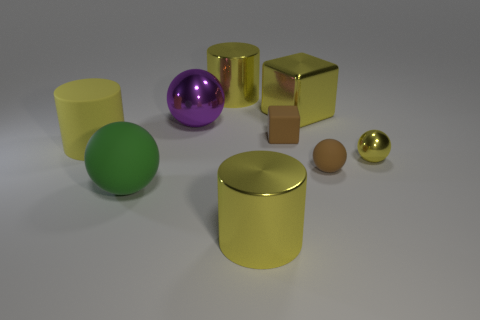Does the big rubber object behind the yellow metal sphere have the same shape as the yellow thing that is in front of the big green ball?
Make the answer very short. Yes. There is a ball that is the same size as the green thing; what is its material?
Your answer should be compact. Metal. How many other things are there of the same material as the yellow ball?
Offer a very short reply. 4. There is a brown matte object behind the large yellow cylinder that is to the left of the purple thing; what is its shape?
Your response must be concise. Cube. How many objects are big cyan matte cubes or yellow things in front of the big yellow block?
Offer a terse response. 3. How many other objects are the same color as the small metallic sphere?
Your response must be concise. 4. How many yellow objects are either small blocks or big metallic cubes?
Your response must be concise. 1. There is a sphere in front of the tiny rubber thing that is on the right side of the tiny cube; is there a large yellow object that is to the left of it?
Provide a short and direct response. Yes. Is the metallic block the same color as the tiny metallic sphere?
Provide a short and direct response. Yes. What is the color of the big object in front of the green object that is in front of the big metallic ball?
Your response must be concise. Yellow. 